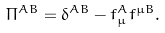<formula> <loc_0><loc_0><loc_500><loc_500>\Pi ^ { A B } = \delta ^ { A B } - f _ { \mu } ^ { A } f ^ { \mu B } .</formula> 